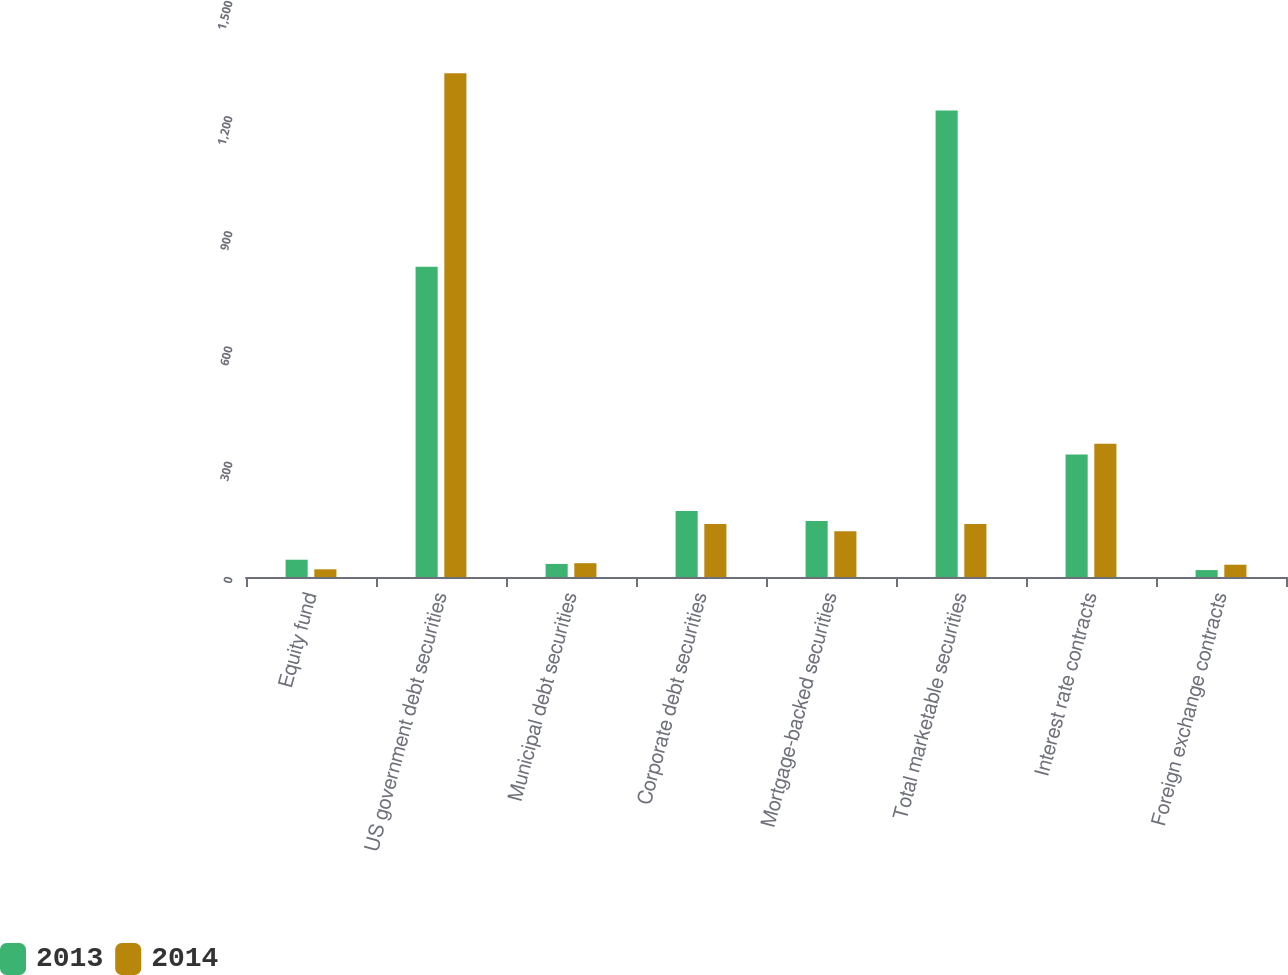<chart> <loc_0><loc_0><loc_500><loc_500><stacked_bar_chart><ecel><fcel>Equity fund<fcel>US government debt securities<fcel>Municipal debt securities<fcel>Corporate debt securities<fcel>Mortgage-backed securities<fcel>Total marketable securities<fcel>Interest rate contracts<fcel>Foreign exchange contracts<nl><fcel>2013<fcel>45<fcel>808<fcel>34<fcel>172<fcel>146<fcel>1215<fcel>319<fcel>18<nl><fcel>2014<fcel>20<fcel>1312<fcel>36<fcel>138<fcel>119<fcel>138<fcel>347<fcel>32<nl></chart> 